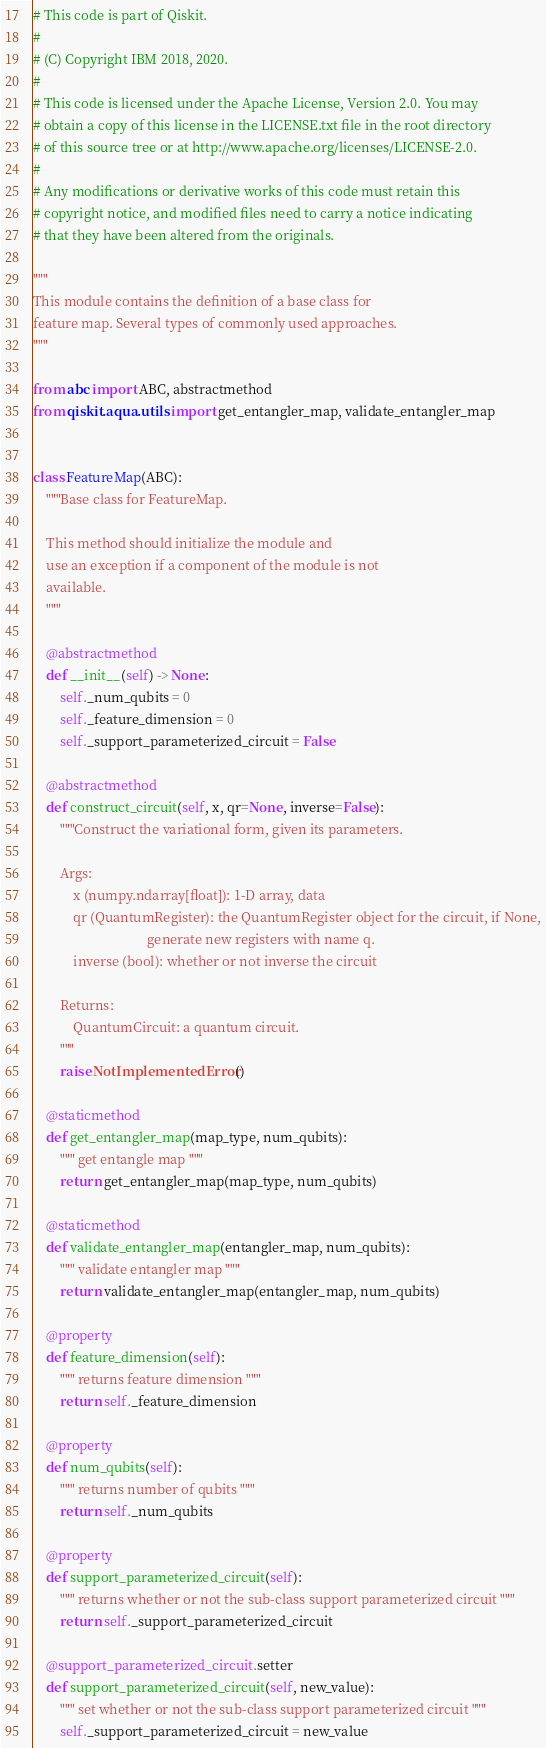Convert code to text. <code><loc_0><loc_0><loc_500><loc_500><_Python_># This code is part of Qiskit.
#
# (C) Copyright IBM 2018, 2020.
#
# This code is licensed under the Apache License, Version 2.0. You may
# obtain a copy of this license in the LICENSE.txt file in the root directory
# of this source tree or at http://www.apache.org/licenses/LICENSE-2.0.
#
# Any modifications or derivative works of this code must retain this
# copyright notice, and modified files need to carry a notice indicating
# that they have been altered from the originals.

"""
This module contains the definition of a base class for
feature map. Several types of commonly used approaches.
"""

from abc import ABC, abstractmethod
from qiskit.aqua.utils import get_entangler_map, validate_entangler_map


class FeatureMap(ABC):
    """Base class for FeatureMap.

    This method should initialize the module and
    use an exception if a component of the module is not
    available.
    """

    @abstractmethod
    def __init__(self) -> None:
        self._num_qubits = 0
        self._feature_dimension = 0
        self._support_parameterized_circuit = False

    @abstractmethod
    def construct_circuit(self, x, qr=None, inverse=False):
        """Construct the variational form, given its parameters.

        Args:
            x (numpy.ndarray[float]): 1-D array, data
            qr (QuantumRegister): the QuantumRegister object for the circuit, if None,
                                  generate new registers with name q.
            inverse (bool): whether or not inverse the circuit

        Returns:
            QuantumCircuit: a quantum circuit.
        """
        raise NotImplementedError()

    @staticmethod
    def get_entangler_map(map_type, num_qubits):
        """ get entangle map """
        return get_entangler_map(map_type, num_qubits)

    @staticmethod
    def validate_entangler_map(entangler_map, num_qubits):
        """ validate entangler map """
        return validate_entangler_map(entangler_map, num_qubits)

    @property
    def feature_dimension(self):
        """ returns feature dimension """
        return self._feature_dimension

    @property
    def num_qubits(self):
        """ returns number of qubits """
        return self._num_qubits

    @property
    def support_parameterized_circuit(self):
        """ returns whether or not the sub-class support parameterized circuit """
        return self._support_parameterized_circuit

    @support_parameterized_circuit.setter
    def support_parameterized_circuit(self, new_value):
        """ set whether or not the sub-class support parameterized circuit """
        self._support_parameterized_circuit = new_value
</code> 